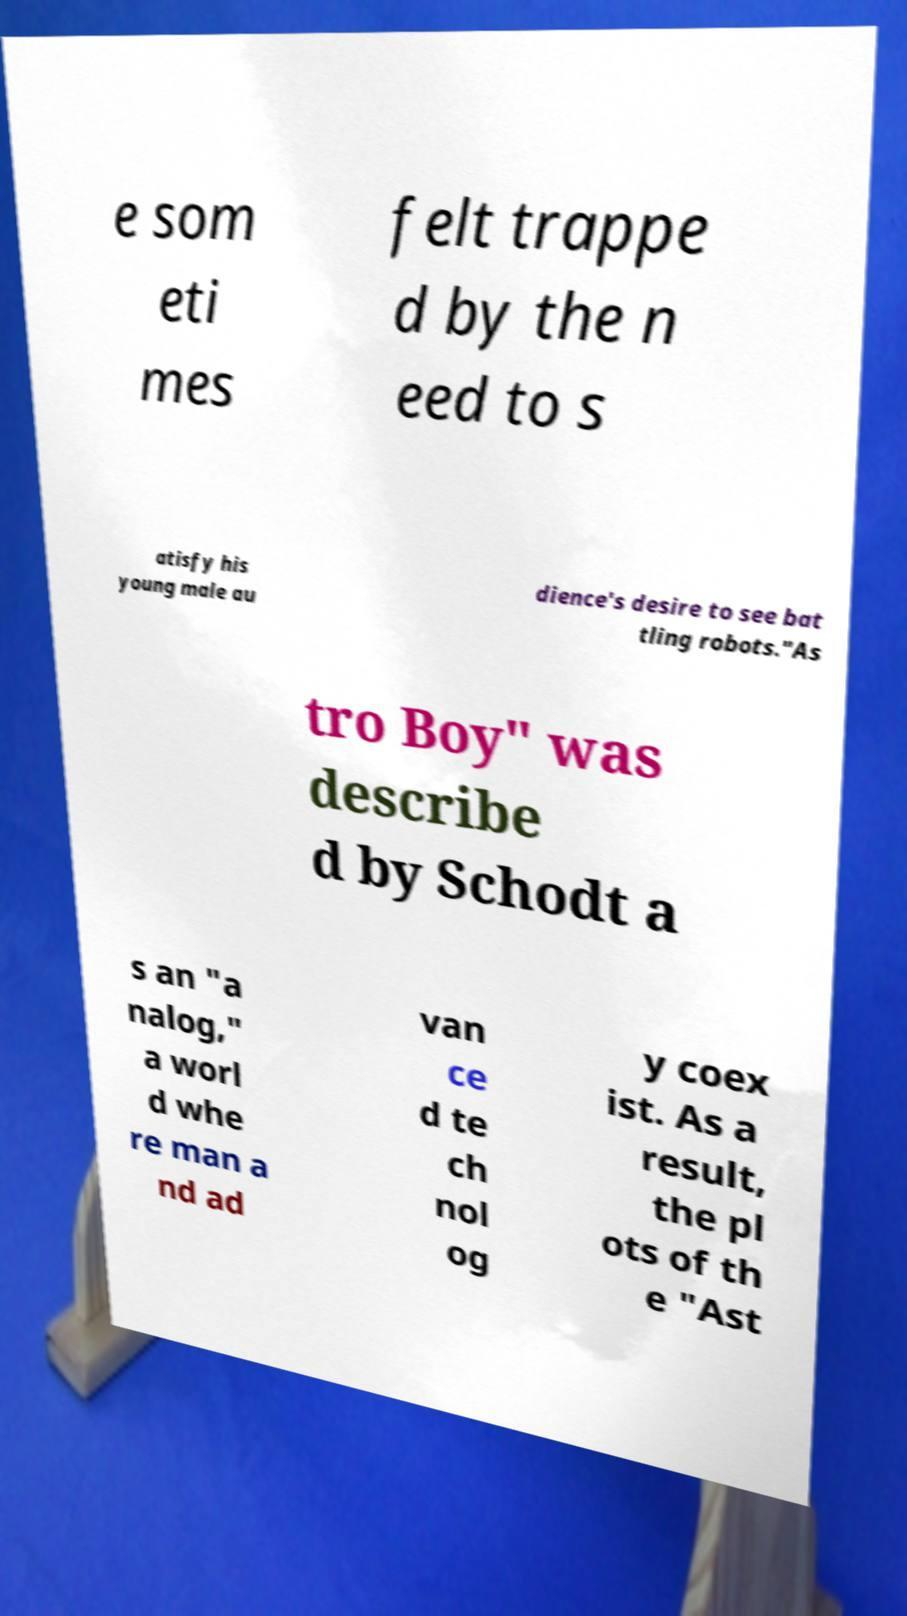Could you assist in decoding the text presented in this image and type it out clearly? e som eti mes felt trappe d by the n eed to s atisfy his young male au dience's desire to see bat tling robots."As tro Boy" was describe d by Schodt a s an "a nalog," a worl d whe re man a nd ad van ce d te ch nol og y coex ist. As a result, the pl ots of th e "Ast 